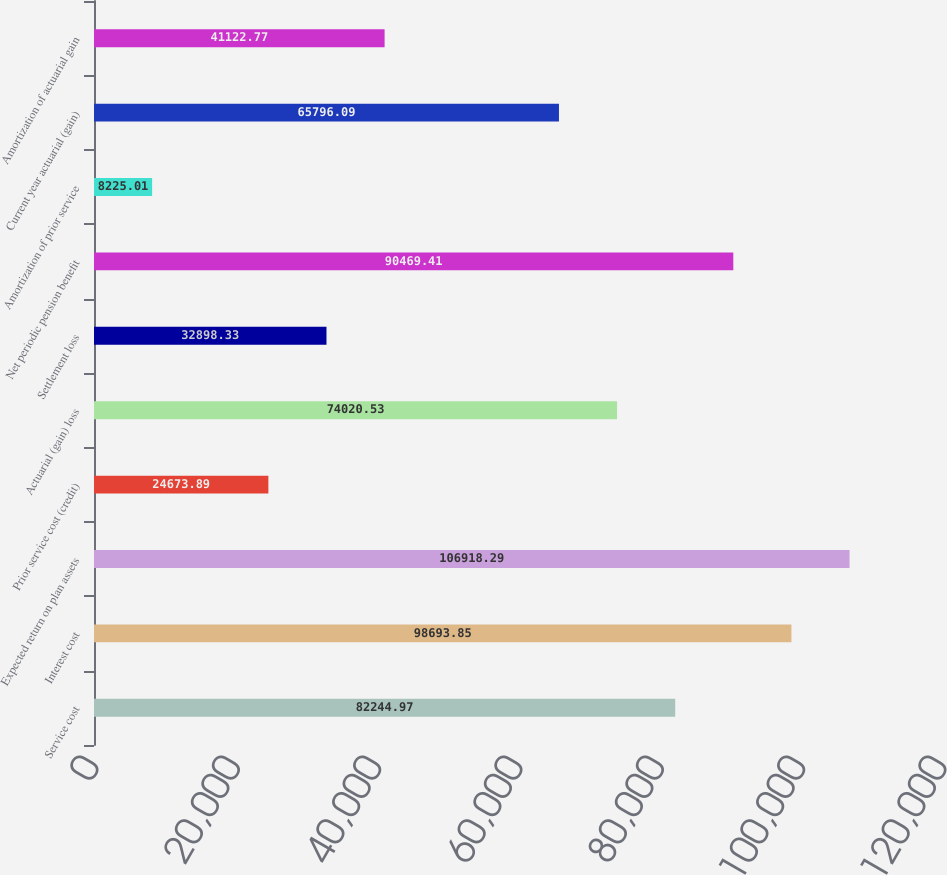Convert chart to OTSL. <chart><loc_0><loc_0><loc_500><loc_500><bar_chart><fcel>Service cost<fcel>Interest cost<fcel>Expected return on plan assets<fcel>Prior service cost (credit)<fcel>Actuarial (gain) loss<fcel>Settlement loss<fcel>Net periodic pension benefit<fcel>Amortization of prior service<fcel>Current year actuarial (gain)<fcel>Amortization of actuarial gain<nl><fcel>82245<fcel>98693.9<fcel>106918<fcel>24673.9<fcel>74020.5<fcel>32898.3<fcel>90469.4<fcel>8225.01<fcel>65796.1<fcel>41122.8<nl></chart> 